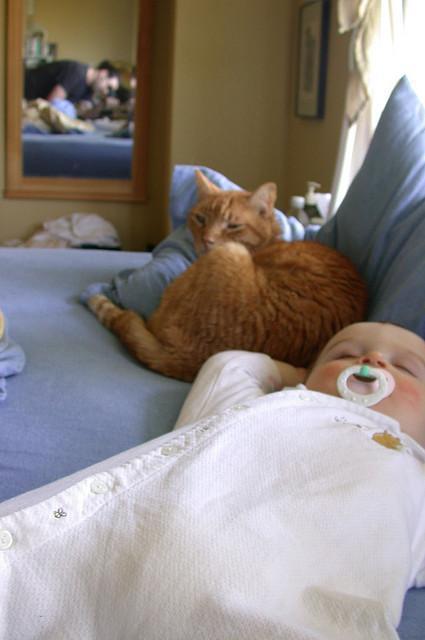How many different living creatures are visible here?
Pick the correct solution from the four options below to address the question.
Options: Three, zero, one, eight. Three. 